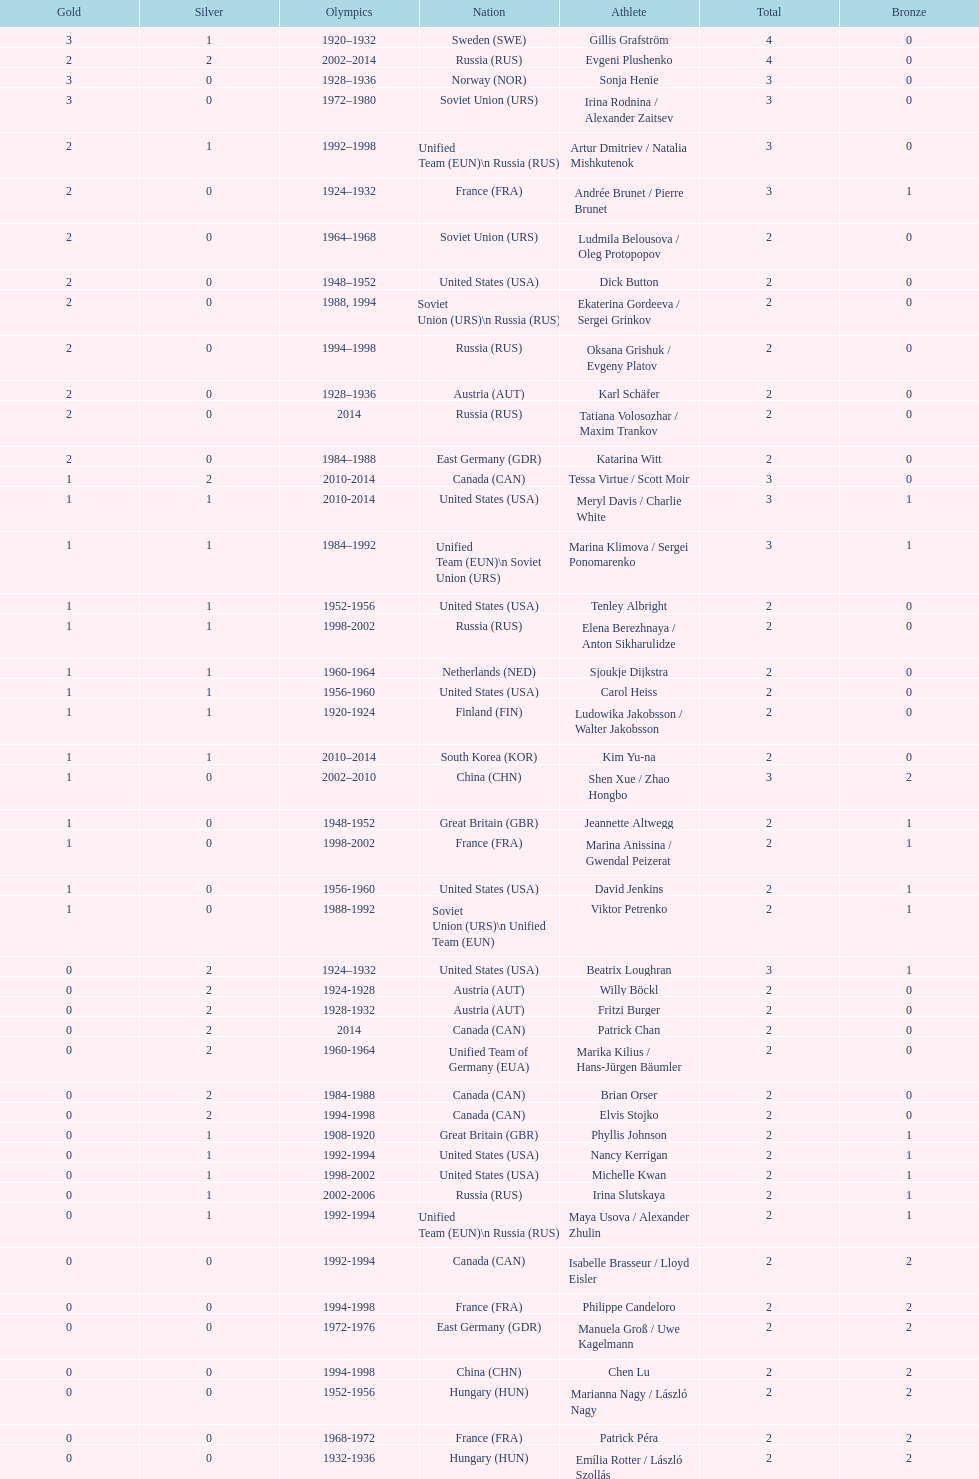Which athlete was from south korea after the year 2010? Kim Yu-na. 